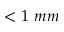Convert formula to latex. <formula><loc_0><loc_0><loc_500><loc_500>< 1 \ m m</formula> 